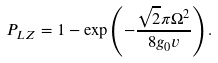Convert formula to latex. <formula><loc_0><loc_0><loc_500><loc_500>P _ { L Z } = 1 - \exp \left ( - \frac { \sqrt { 2 } \pi \Omega ^ { 2 } } { 8 g _ { 0 } v } \right ) .</formula> 